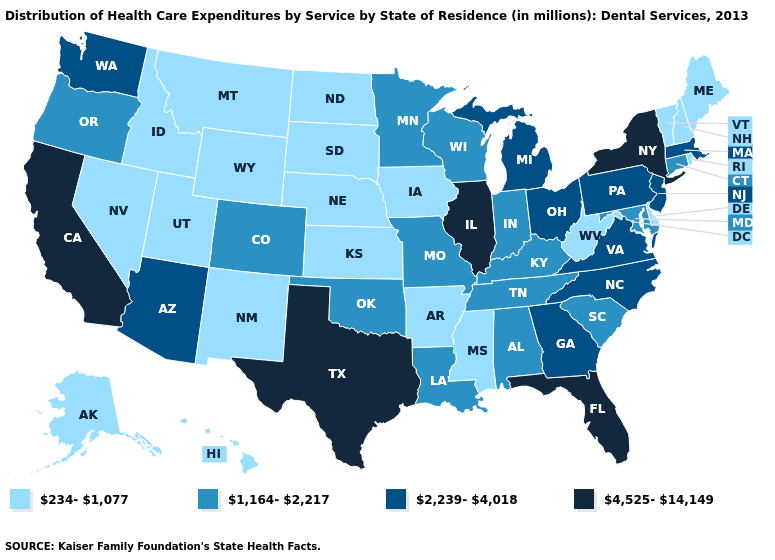Name the states that have a value in the range 234-1,077?
Keep it brief. Alaska, Arkansas, Delaware, Hawaii, Idaho, Iowa, Kansas, Maine, Mississippi, Montana, Nebraska, Nevada, New Hampshire, New Mexico, North Dakota, Rhode Island, South Dakota, Utah, Vermont, West Virginia, Wyoming. Which states have the highest value in the USA?
Write a very short answer. California, Florida, Illinois, New York, Texas. What is the value of Hawaii?
Write a very short answer. 234-1,077. What is the value of Nebraska?
Give a very brief answer. 234-1,077. What is the lowest value in states that border Colorado?
Answer briefly. 234-1,077. Does Oregon have the lowest value in the USA?
Short answer required. No. What is the value of New Hampshire?
Quick response, please. 234-1,077. How many symbols are there in the legend?
Quick response, please. 4. What is the highest value in states that border Michigan?
Write a very short answer. 2,239-4,018. Name the states that have a value in the range 1,164-2,217?
Answer briefly. Alabama, Colorado, Connecticut, Indiana, Kentucky, Louisiana, Maryland, Minnesota, Missouri, Oklahoma, Oregon, South Carolina, Tennessee, Wisconsin. Among the states that border Alabama , which have the highest value?
Quick response, please. Florida. Which states have the lowest value in the West?
Quick response, please. Alaska, Hawaii, Idaho, Montana, Nevada, New Mexico, Utah, Wyoming. What is the lowest value in the USA?
Give a very brief answer. 234-1,077. Does the map have missing data?
Answer briefly. No. Name the states that have a value in the range 2,239-4,018?
Give a very brief answer. Arizona, Georgia, Massachusetts, Michigan, New Jersey, North Carolina, Ohio, Pennsylvania, Virginia, Washington. 